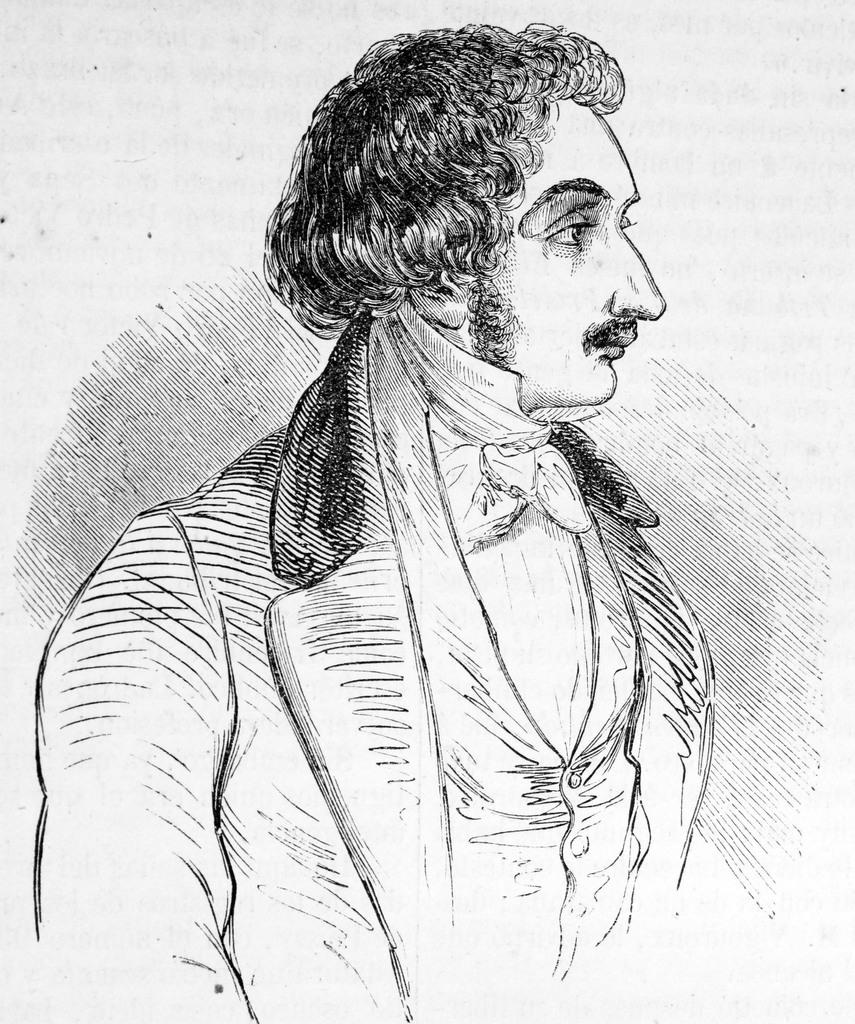What is the main subject of the image? The main subject of the image is a sketch of a man. What facial feature does the man in the sketch have? The man in the sketch has a mustache. What color is the background of the image? The background of the image is white. How many beads are hanging from the man's mustache in the image? There are no beads present in the image, as it is a sketch of a man with a mustache and no additional objects or features. 